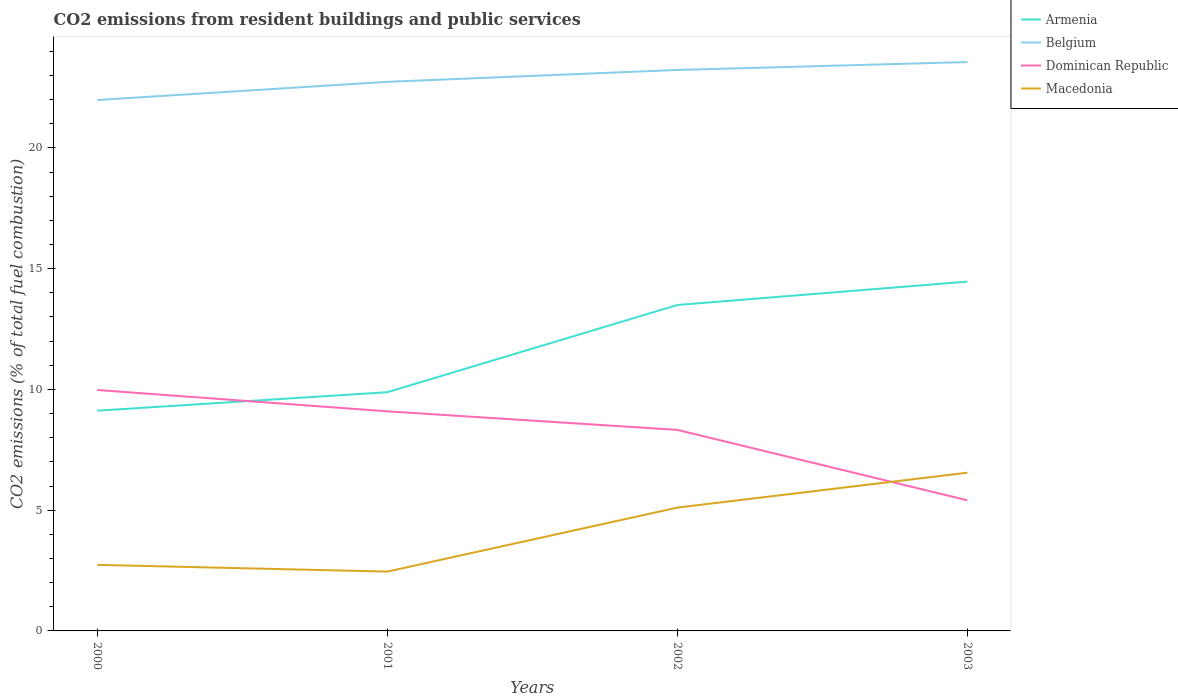Across all years, what is the maximum total CO2 emitted in Belgium?
Your answer should be compact. 21.98. In which year was the total CO2 emitted in Armenia maximum?
Your response must be concise. 2000. What is the total total CO2 emitted in Belgium in the graph?
Give a very brief answer. -0.75. What is the difference between the highest and the second highest total CO2 emitted in Belgium?
Ensure brevity in your answer.  1.57. Is the total CO2 emitted in Belgium strictly greater than the total CO2 emitted in Dominican Republic over the years?
Keep it short and to the point. No. How many years are there in the graph?
Offer a very short reply. 4. Are the values on the major ticks of Y-axis written in scientific E-notation?
Your answer should be very brief. No. Does the graph contain any zero values?
Your answer should be compact. No. Where does the legend appear in the graph?
Give a very brief answer. Top right. How are the legend labels stacked?
Offer a very short reply. Vertical. What is the title of the graph?
Your answer should be very brief. CO2 emissions from resident buildings and public services. Does "Panama" appear as one of the legend labels in the graph?
Offer a terse response. No. What is the label or title of the X-axis?
Provide a short and direct response. Years. What is the label or title of the Y-axis?
Your answer should be compact. CO2 emissions (% of total fuel combustion). What is the CO2 emissions (% of total fuel combustion) in Armenia in 2000?
Your answer should be very brief. 9.12. What is the CO2 emissions (% of total fuel combustion) in Belgium in 2000?
Your answer should be compact. 21.98. What is the CO2 emissions (% of total fuel combustion) of Dominican Republic in 2000?
Your answer should be very brief. 9.98. What is the CO2 emissions (% of total fuel combustion) in Macedonia in 2000?
Provide a short and direct response. 2.73. What is the CO2 emissions (% of total fuel combustion) in Armenia in 2001?
Ensure brevity in your answer.  9.88. What is the CO2 emissions (% of total fuel combustion) in Belgium in 2001?
Offer a terse response. 22.73. What is the CO2 emissions (% of total fuel combustion) in Dominican Republic in 2001?
Offer a terse response. 9.09. What is the CO2 emissions (% of total fuel combustion) in Macedonia in 2001?
Provide a succinct answer. 2.46. What is the CO2 emissions (% of total fuel combustion) in Armenia in 2002?
Your answer should be compact. 13.49. What is the CO2 emissions (% of total fuel combustion) in Belgium in 2002?
Make the answer very short. 23.23. What is the CO2 emissions (% of total fuel combustion) in Dominican Republic in 2002?
Your response must be concise. 8.32. What is the CO2 emissions (% of total fuel combustion) in Macedonia in 2002?
Offer a terse response. 5.11. What is the CO2 emissions (% of total fuel combustion) of Armenia in 2003?
Your answer should be very brief. 14.46. What is the CO2 emissions (% of total fuel combustion) of Belgium in 2003?
Provide a succinct answer. 23.55. What is the CO2 emissions (% of total fuel combustion) of Dominican Republic in 2003?
Make the answer very short. 5.41. What is the CO2 emissions (% of total fuel combustion) in Macedonia in 2003?
Provide a short and direct response. 6.55. Across all years, what is the maximum CO2 emissions (% of total fuel combustion) in Armenia?
Your answer should be very brief. 14.46. Across all years, what is the maximum CO2 emissions (% of total fuel combustion) in Belgium?
Your answer should be very brief. 23.55. Across all years, what is the maximum CO2 emissions (% of total fuel combustion) in Dominican Republic?
Ensure brevity in your answer.  9.98. Across all years, what is the maximum CO2 emissions (% of total fuel combustion) in Macedonia?
Give a very brief answer. 6.55. Across all years, what is the minimum CO2 emissions (% of total fuel combustion) of Armenia?
Provide a succinct answer. 9.12. Across all years, what is the minimum CO2 emissions (% of total fuel combustion) of Belgium?
Provide a short and direct response. 21.98. Across all years, what is the minimum CO2 emissions (% of total fuel combustion) in Dominican Republic?
Make the answer very short. 5.41. Across all years, what is the minimum CO2 emissions (% of total fuel combustion) of Macedonia?
Ensure brevity in your answer.  2.46. What is the total CO2 emissions (% of total fuel combustion) of Armenia in the graph?
Your response must be concise. 46.96. What is the total CO2 emissions (% of total fuel combustion) of Belgium in the graph?
Keep it short and to the point. 91.49. What is the total CO2 emissions (% of total fuel combustion) in Dominican Republic in the graph?
Offer a very short reply. 32.8. What is the total CO2 emissions (% of total fuel combustion) of Macedonia in the graph?
Your response must be concise. 16.85. What is the difference between the CO2 emissions (% of total fuel combustion) in Armenia in 2000 and that in 2001?
Your answer should be compact. -0.77. What is the difference between the CO2 emissions (% of total fuel combustion) in Belgium in 2000 and that in 2001?
Provide a short and direct response. -0.75. What is the difference between the CO2 emissions (% of total fuel combustion) of Dominican Republic in 2000 and that in 2001?
Your answer should be very brief. 0.88. What is the difference between the CO2 emissions (% of total fuel combustion) of Macedonia in 2000 and that in 2001?
Keep it short and to the point. 0.28. What is the difference between the CO2 emissions (% of total fuel combustion) in Armenia in 2000 and that in 2002?
Keep it short and to the point. -4.38. What is the difference between the CO2 emissions (% of total fuel combustion) in Belgium in 2000 and that in 2002?
Give a very brief answer. -1.24. What is the difference between the CO2 emissions (% of total fuel combustion) in Dominican Republic in 2000 and that in 2002?
Your answer should be compact. 1.65. What is the difference between the CO2 emissions (% of total fuel combustion) in Macedonia in 2000 and that in 2002?
Provide a short and direct response. -2.37. What is the difference between the CO2 emissions (% of total fuel combustion) in Armenia in 2000 and that in 2003?
Keep it short and to the point. -5.34. What is the difference between the CO2 emissions (% of total fuel combustion) in Belgium in 2000 and that in 2003?
Make the answer very short. -1.57. What is the difference between the CO2 emissions (% of total fuel combustion) of Dominican Republic in 2000 and that in 2003?
Ensure brevity in your answer.  4.57. What is the difference between the CO2 emissions (% of total fuel combustion) of Macedonia in 2000 and that in 2003?
Keep it short and to the point. -3.82. What is the difference between the CO2 emissions (% of total fuel combustion) of Armenia in 2001 and that in 2002?
Your answer should be compact. -3.61. What is the difference between the CO2 emissions (% of total fuel combustion) in Belgium in 2001 and that in 2002?
Ensure brevity in your answer.  -0.49. What is the difference between the CO2 emissions (% of total fuel combustion) of Dominican Republic in 2001 and that in 2002?
Your answer should be very brief. 0.77. What is the difference between the CO2 emissions (% of total fuel combustion) in Macedonia in 2001 and that in 2002?
Provide a succinct answer. -2.65. What is the difference between the CO2 emissions (% of total fuel combustion) of Armenia in 2001 and that in 2003?
Provide a succinct answer. -4.58. What is the difference between the CO2 emissions (% of total fuel combustion) in Belgium in 2001 and that in 2003?
Your answer should be compact. -0.82. What is the difference between the CO2 emissions (% of total fuel combustion) of Dominican Republic in 2001 and that in 2003?
Make the answer very short. 3.68. What is the difference between the CO2 emissions (% of total fuel combustion) in Macedonia in 2001 and that in 2003?
Ensure brevity in your answer.  -4.1. What is the difference between the CO2 emissions (% of total fuel combustion) in Armenia in 2002 and that in 2003?
Provide a short and direct response. -0.97. What is the difference between the CO2 emissions (% of total fuel combustion) of Belgium in 2002 and that in 2003?
Offer a terse response. -0.33. What is the difference between the CO2 emissions (% of total fuel combustion) in Dominican Republic in 2002 and that in 2003?
Ensure brevity in your answer.  2.92. What is the difference between the CO2 emissions (% of total fuel combustion) in Macedonia in 2002 and that in 2003?
Keep it short and to the point. -1.45. What is the difference between the CO2 emissions (% of total fuel combustion) of Armenia in 2000 and the CO2 emissions (% of total fuel combustion) of Belgium in 2001?
Offer a very short reply. -13.62. What is the difference between the CO2 emissions (% of total fuel combustion) in Armenia in 2000 and the CO2 emissions (% of total fuel combustion) in Dominican Republic in 2001?
Your answer should be very brief. 0.03. What is the difference between the CO2 emissions (% of total fuel combustion) in Armenia in 2000 and the CO2 emissions (% of total fuel combustion) in Macedonia in 2001?
Offer a terse response. 6.66. What is the difference between the CO2 emissions (% of total fuel combustion) in Belgium in 2000 and the CO2 emissions (% of total fuel combustion) in Dominican Republic in 2001?
Keep it short and to the point. 12.89. What is the difference between the CO2 emissions (% of total fuel combustion) of Belgium in 2000 and the CO2 emissions (% of total fuel combustion) of Macedonia in 2001?
Provide a succinct answer. 19.52. What is the difference between the CO2 emissions (% of total fuel combustion) of Dominican Republic in 2000 and the CO2 emissions (% of total fuel combustion) of Macedonia in 2001?
Provide a succinct answer. 7.52. What is the difference between the CO2 emissions (% of total fuel combustion) in Armenia in 2000 and the CO2 emissions (% of total fuel combustion) in Belgium in 2002?
Make the answer very short. -14.11. What is the difference between the CO2 emissions (% of total fuel combustion) of Armenia in 2000 and the CO2 emissions (% of total fuel combustion) of Dominican Republic in 2002?
Provide a short and direct response. 0.79. What is the difference between the CO2 emissions (% of total fuel combustion) in Armenia in 2000 and the CO2 emissions (% of total fuel combustion) in Macedonia in 2002?
Ensure brevity in your answer.  4.01. What is the difference between the CO2 emissions (% of total fuel combustion) in Belgium in 2000 and the CO2 emissions (% of total fuel combustion) in Dominican Republic in 2002?
Your response must be concise. 13.66. What is the difference between the CO2 emissions (% of total fuel combustion) of Belgium in 2000 and the CO2 emissions (% of total fuel combustion) of Macedonia in 2002?
Give a very brief answer. 16.88. What is the difference between the CO2 emissions (% of total fuel combustion) of Dominican Republic in 2000 and the CO2 emissions (% of total fuel combustion) of Macedonia in 2002?
Provide a succinct answer. 4.87. What is the difference between the CO2 emissions (% of total fuel combustion) in Armenia in 2000 and the CO2 emissions (% of total fuel combustion) in Belgium in 2003?
Your answer should be very brief. -14.43. What is the difference between the CO2 emissions (% of total fuel combustion) in Armenia in 2000 and the CO2 emissions (% of total fuel combustion) in Dominican Republic in 2003?
Make the answer very short. 3.71. What is the difference between the CO2 emissions (% of total fuel combustion) in Armenia in 2000 and the CO2 emissions (% of total fuel combustion) in Macedonia in 2003?
Your answer should be compact. 2.57. What is the difference between the CO2 emissions (% of total fuel combustion) in Belgium in 2000 and the CO2 emissions (% of total fuel combustion) in Dominican Republic in 2003?
Ensure brevity in your answer.  16.57. What is the difference between the CO2 emissions (% of total fuel combustion) of Belgium in 2000 and the CO2 emissions (% of total fuel combustion) of Macedonia in 2003?
Ensure brevity in your answer.  15.43. What is the difference between the CO2 emissions (% of total fuel combustion) of Dominican Republic in 2000 and the CO2 emissions (% of total fuel combustion) of Macedonia in 2003?
Give a very brief answer. 3.42. What is the difference between the CO2 emissions (% of total fuel combustion) in Armenia in 2001 and the CO2 emissions (% of total fuel combustion) in Belgium in 2002?
Keep it short and to the point. -13.34. What is the difference between the CO2 emissions (% of total fuel combustion) in Armenia in 2001 and the CO2 emissions (% of total fuel combustion) in Dominican Republic in 2002?
Offer a very short reply. 1.56. What is the difference between the CO2 emissions (% of total fuel combustion) in Armenia in 2001 and the CO2 emissions (% of total fuel combustion) in Macedonia in 2002?
Your response must be concise. 4.78. What is the difference between the CO2 emissions (% of total fuel combustion) in Belgium in 2001 and the CO2 emissions (% of total fuel combustion) in Dominican Republic in 2002?
Your response must be concise. 14.41. What is the difference between the CO2 emissions (% of total fuel combustion) of Belgium in 2001 and the CO2 emissions (% of total fuel combustion) of Macedonia in 2002?
Provide a succinct answer. 17.63. What is the difference between the CO2 emissions (% of total fuel combustion) in Dominican Republic in 2001 and the CO2 emissions (% of total fuel combustion) in Macedonia in 2002?
Your answer should be very brief. 3.99. What is the difference between the CO2 emissions (% of total fuel combustion) of Armenia in 2001 and the CO2 emissions (% of total fuel combustion) of Belgium in 2003?
Ensure brevity in your answer.  -13.67. What is the difference between the CO2 emissions (% of total fuel combustion) in Armenia in 2001 and the CO2 emissions (% of total fuel combustion) in Dominican Republic in 2003?
Your answer should be compact. 4.48. What is the difference between the CO2 emissions (% of total fuel combustion) of Armenia in 2001 and the CO2 emissions (% of total fuel combustion) of Macedonia in 2003?
Keep it short and to the point. 3.33. What is the difference between the CO2 emissions (% of total fuel combustion) in Belgium in 2001 and the CO2 emissions (% of total fuel combustion) in Dominican Republic in 2003?
Provide a succinct answer. 17.33. What is the difference between the CO2 emissions (% of total fuel combustion) of Belgium in 2001 and the CO2 emissions (% of total fuel combustion) of Macedonia in 2003?
Your response must be concise. 16.18. What is the difference between the CO2 emissions (% of total fuel combustion) in Dominican Republic in 2001 and the CO2 emissions (% of total fuel combustion) in Macedonia in 2003?
Make the answer very short. 2.54. What is the difference between the CO2 emissions (% of total fuel combustion) of Armenia in 2002 and the CO2 emissions (% of total fuel combustion) of Belgium in 2003?
Give a very brief answer. -10.06. What is the difference between the CO2 emissions (% of total fuel combustion) in Armenia in 2002 and the CO2 emissions (% of total fuel combustion) in Dominican Republic in 2003?
Make the answer very short. 8.09. What is the difference between the CO2 emissions (% of total fuel combustion) of Armenia in 2002 and the CO2 emissions (% of total fuel combustion) of Macedonia in 2003?
Your answer should be compact. 6.94. What is the difference between the CO2 emissions (% of total fuel combustion) of Belgium in 2002 and the CO2 emissions (% of total fuel combustion) of Dominican Republic in 2003?
Offer a very short reply. 17.82. What is the difference between the CO2 emissions (% of total fuel combustion) of Belgium in 2002 and the CO2 emissions (% of total fuel combustion) of Macedonia in 2003?
Offer a terse response. 16.67. What is the difference between the CO2 emissions (% of total fuel combustion) in Dominican Republic in 2002 and the CO2 emissions (% of total fuel combustion) in Macedonia in 2003?
Your answer should be compact. 1.77. What is the average CO2 emissions (% of total fuel combustion) in Armenia per year?
Ensure brevity in your answer.  11.74. What is the average CO2 emissions (% of total fuel combustion) in Belgium per year?
Keep it short and to the point. 22.87. What is the average CO2 emissions (% of total fuel combustion) in Dominican Republic per year?
Give a very brief answer. 8.2. What is the average CO2 emissions (% of total fuel combustion) in Macedonia per year?
Offer a terse response. 4.21. In the year 2000, what is the difference between the CO2 emissions (% of total fuel combustion) of Armenia and CO2 emissions (% of total fuel combustion) of Belgium?
Your answer should be very brief. -12.86. In the year 2000, what is the difference between the CO2 emissions (% of total fuel combustion) of Armenia and CO2 emissions (% of total fuel combustion) of Dominican Republic?
Keep it short and to the point. -0.86. In the year 2000, what is the difference between the CO2 emissions (% of total fuel combustion) of Armenia and CO2 emissions (% of total fuel combustion) of Macedonia?
Provide a succinct answer. 6.38. In the year 2000, what is the difference between the CO2 emissions (% of total fuel combustion) in Belgium and CO2 emissions (% of total fuel combustion) in Dominican Republic?
Keep it short and to the point. 12.01. In the year 2000, what is the difference between the CO2 emissions (% of total fuel combustion) in Belgium and CO2 emissions (% of total fuel combustion) in Macedonia?
Give a very brief answer. 19.25. In the year 2000, what is the difference between the CO2 emissions (% of total fuel combustion) of Dominican Republic and CO2 emissions (% of total fuel combustion) of Macedonia?
Keep it short and to the point. 7.24. In the year 2001, what is the difference between the CO2 emissions (% of total fuel combustion) of Armenia and CO2 emissions (% of total fuel combustion) of Belgium?
Offer a terse response. -12.85. In the year 2001, what is the difference between the CO2 emissions (% of total fuel combustion) in Armenia and CO2 emissions (% of total fuel combustion) in Dominican Republic?
Ensure brevity in your answer.  0.79. In the year 2001, what is the difference between the CO2 emissions (% of total fuel combustion) in Armenia and CO2 emissions (% of total fuel combustion) in Macedonia?
Ensure brevity in your answer.  7.43. In the year 2001, what is the difference between the CO2 emissions (% of total fuel combustion) of Belgium and CO2 emissions (% of total fuel combustion) of Dominican Republic?
Offer a terse response. 13.64. In the year 2001, what is the difference between the CO2 emissions (% of total fuel combustion) of Belgium and CO2 emissions (% of total fuel combustion) of Macedonia?
Offer a very short reply. 20.28. In the year 2001, what is the difference between the CO2 emissions (% of total fuel combustion) of Dominican Republic and CO2 emissions (% of total fuel combustion) of Macedonia?
Offer a very short reply. 6.63. In the year 2002, what is the difference between the CO2 emissions (% of total fuel combustion) of Armenia and CO2 emissions (% of total fuel combustion) of Belgium?
Provide a short and direct response. -9.73. In the year 2002, what is the difference between the CO2 emissions (% of total fuel combustion) in Armenia and CO2 emissions (% of total fuel combustion) in Dominican Republic?
Make the answer very short. 5.17. In the year 2002, what is the difference between the CO2 emissions (% of total fuel combustion) of Armenia and CO2 emissions (% of total fuel combustion) of Macedonia?
Keep it short and to the point. 8.39. In the year 2002, what is the difference between the CO2 emissions (% of total fuel combustion) in Belgium and CO2 emissions (% of total fuel combustion) in Dominican Republic?
Offer a terse response. 14.9. In the year 2002, what is the difference between the CO2 emissions (% of total fuel combustion) in Belgium and CO2 emissions (% of total fuel combustion) in Macedonia?
Your response must be concise. 18.12. In the year 2002, what is the difference between the CO2 emissions (% of total fuel combustion) in Dominican Republic and CO2 emissions (% of total fuel combustion) in Macedonia?
Your answer should be very brief. 3.22. In the year 2003, what is the difference between the CO2 emissions (% of total fuel combustion) of Armenia and CO2 emissions (% of total fuel combustion) of Belgium?
Your answer should be compact. -9.09. In the year 2003, what is the difference between the CO2 emissions (% of total fuel combustion) of Armenia and CO2 emissions (% of total fuel combustion) of Dominican Republic?
Your response must be concise. 9.05. In the year 2003, what is the difference between the CO2 emissions (% of total fuel combustion) in Armenia and CO2 emissions (% of total fuel combustion) in Macedonia?
Provide a short and direct response. 7.91. In the year 2003, what is the difference between the CO2 emissions (% of total fuel combustion) of Belgium and CO2 emissions (% of total fuel combustion) of Dominican Republic?
Offer a very short reply. 18.15. In the year 2003, what is the difference between the CO2 emissions (% of total fuel combustion) in Belgium and CO2 emissions (% of total fuel combustion) in Macedonia?
Make the answer very short. 17. In the year 2003, what is the difference between the CO2 emissions (% of total fuel combustion) in Dominican Republic and CO2 emissions (% of total fuel combustion) in Macedonia?
Make the answer very short. -1.14. What is the ratio of the CO2 emissions (% of total fuel combustion) in Armenia in 2000 to that in 2001?
Keep it short and to the point. 0.92. What is the ratio of the CO2 emissions (% of total fuel combustion) of Belgium in 2000 to that in 2001?
Your answer should be very brief. 0.97. What is the ratio of the CO2 emissions (% of total fuel combustion) in Dominican Republic in 2000 to that in 2001?
Your answer should be compact. 1.1. What is the ratio of the CO2 emissions (% of total fuel combustion) of Macedonia in 2000 to that in 2001?
Provide a short and direct response. 1.11. What is the ratio of the CO2 emissions (% of total fuel combustion) in Armenia in 2000 to that in 2002?
Make the answer very short. 0.68. What is the ratio of the CO2 emissions (% of total fuel combustion) in Belgium in 2000 to that in 2002?
Make the answer very short. 0.95. What is the ratio of the CO2 emissions (% of total fuel combustion) of Dominican Republic in 2000 to that in 2002?
Your response must be concise. 1.2. What is the ratio of the CO2 emissions (% of total fuel combustion) in Macedonia in 2000 to that in 2002?
Keep it short and to the point. 0.54. What is the ratio of the CO2 emissions (% of total fuel combustion) of Armenia in 2000 to that in 2003?
Offer a terse response. 0.63. What is the ratio of the CO2 emissions (% of total fuel combustion) in Dominican Republic in 2000 to that in 2003?
Your answer should be compact. 1.84. What is the ratio of the CO2 emissions (% of total fuel combustion) in Macedonia in 2000 to that in 2003?
Give a very brief answer. 0.42. What is the ratio of the CO2 emissions (% of total fuel combustion) in Armenia in 2001 to that in 2002?
Your response must be concise. 0.73. What is the ratio of the CO2 emissions (% of total fuel combustion) in Belgium in 2001 to that in 2002?
Your answer should be very brief. 0.98. What is the ratio of the CO2 emissions (% of total fuel combustion) of Dominican Republic in 2001 to that in 2002?
Ensure brevity in your answer.  1.09. What is the ratio of the CO2 emissions (% of total fuel combustion) in Macedonia in 2001 to that in 2002?
Your response must be concise. 0.48. What is the ratio of the CO2 emissions (% of total fuel combustion) in Armenia in 2001 to that in 2003?
Give a very brief answer. 0.68. What is the ratio of the CO2 emissions (% of total fuel combustion) in Belgium in 2001 to that in 2003?
Your response must be concise. 0.97. What is the ratio of the CO2 emissions (% of total fuel combustion) in Dominican Republic in 2001 to that in 2003?
Your answer should be compact. 1.68. What is the ratio of the CO2 emissions (% of total fuel combustion) of Macedonia in 2001 to that in 2003?
Make the answer very short. 0.37. What is the ratio of the CO2 emissions (% of total fuel combustion) in Armenia in 2002 to that in 2003?
Your response must be concise. 0.93. What is the ratio of the CO2 emissions (% of total fuel combustion) of Belgium in 2002 to that in 2003?
Provide a succinct answer. 0.99. What is the ratio of the CO2 emissions (% of total fuel combustion) of Dominican Republic in 2002 to that in 2003?
Your response must be concise. 1.54. What is the ratio of the CO2 emissions (% of total fuel combustion) of Macedonia in 2002 to that in 2003?
Your answer should be very brief. 0.78. What is the difference between the highest and the second highest CO2 emissions (% of total fuel combustion) of Armenia?
Provide a succinct answer. 0.97. What is the difference between the highest and the second highest CO2 emissions (% of total fuel combustion) in Belgium?
Make the answer very short. 0.33. What is the difference between the highest and the second highest CO2 emissions (% of total fuel combustion) in Dominican Republic?
Your response must be concise. 0.88. What is the difference between the highest and the second highest CO2 emissions (% of total fuel combustion) of Macedonia?
Ensure brevity in your answer.  1.45. What is the difference between the highest and the lowest CO2 emissions (% of total fuel combustion) of Armenia?
Your response must be concise. 5.34. What is the difference between the highest and the lowest CO2 emissions (% of total fuel combustion) in Belgium?
Your answer should be very brief. 1.57. What is the difference between the highest and the lowest CO2 emissions (% of total fuel combustion) of Dominican Republic?
Provide a short and direct response. 4.57. What is the difference between the highest and the lowest CO2 emissions (% of total fuel combustion) in Macedonia?
Provide a short and direct response. 4.1. 